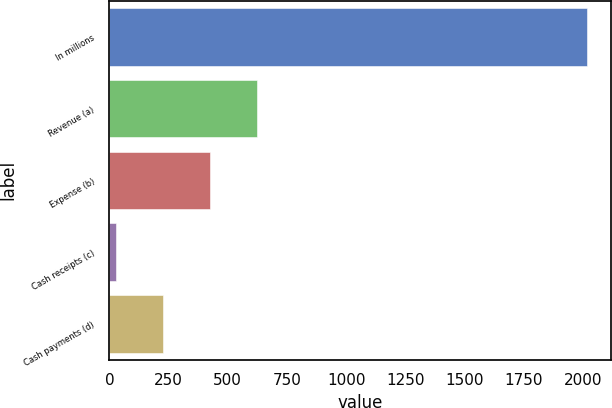<chart> <loc_0><loc_0><loc_500><loc_500><bar_chart><fcel>In millions<fcel>Revenue (a)<fcel>Expense (b)<fcel>Cash receipts (c)<fcel>Cash payments (d)<nl><fcel>2017<fcel>624.7<fcel>425.8<fcel>28<fcel>226.9<nl></chart> 